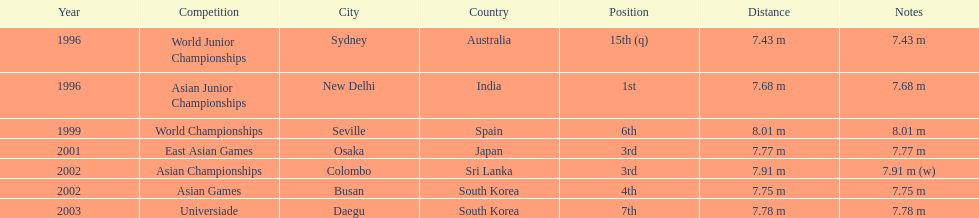I'm looking to parse the entire table for insights. Could you assist me with that? {'header': ['Year', 'Competition', 'City', 'Country', 'Position', 'Distance', 'Notes'], 'rows': [['1996', 'World Junior Championships', 'Sydney', 'Australia', '15th (q)', '7.43 m', '7.43 m'], ['1996', 'Asian Junior Championships', 'New Delhi', 'India', '1st', '7.68 m', '7.68 m'], ['1999', 'World Championships', 'Seville', 'Spain', '6th', '8.01 m', '8.01 m'], ['2001', 'East Asian Games', 'Osaka', 'Japan', '3rd', '7.77 m', '7.77 m'], ['2002', 'Asian Championships', 'Colombo', 'Sri Lanka', '3rd', '7.91 m', '7.91 m (w)'], ['2002', 'Asian Games', 'Busan', 'South Korea', '4th', '7.75 m', '7.75 m'], ['2003', 'Universiade', 'Daegu', 'South Korea', '7th', '7.78 m', '7.78 m']]} What was the venue when he placed first? New Delhi, India. 